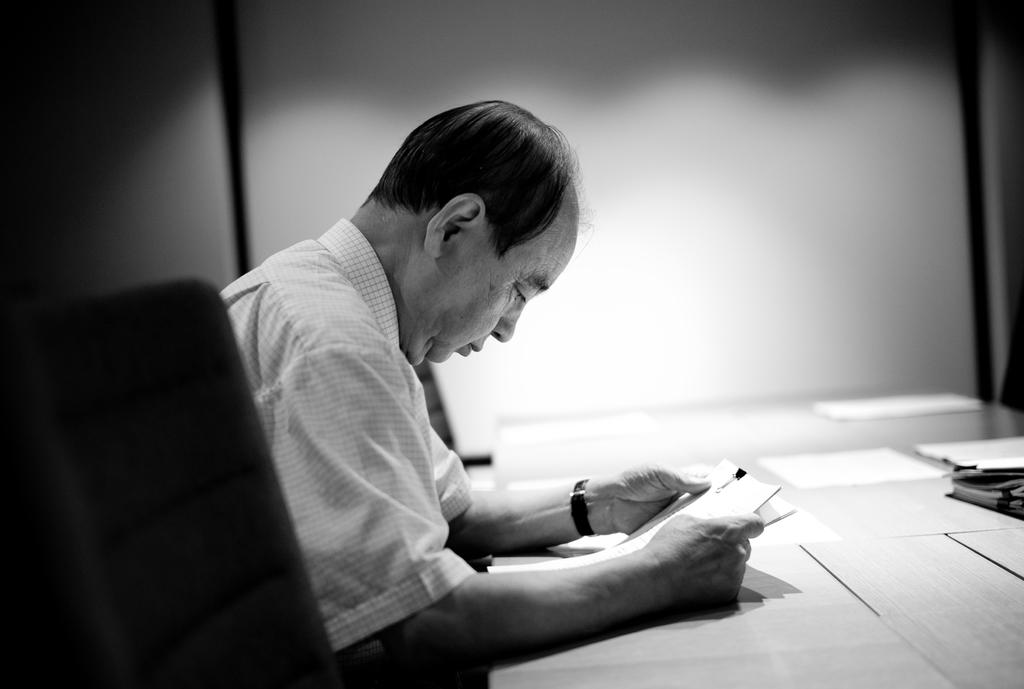Who is present in the image? There is a man in the image. What is the man doing in the image? The man is seated on a chair in the image. What is the man holding in his hand? The man is holding a book in his hand. What else can be seen on the table in the image? There are papers on the table in the image. What is the relationship between the man and his brother in the image? There is no mention of a brother in the image, so we cannot determine the relationship between the man and a brother. What color is the blood on the man's back in the image? There is no blood or mention of a back in the image, so we cannot answer this question. 